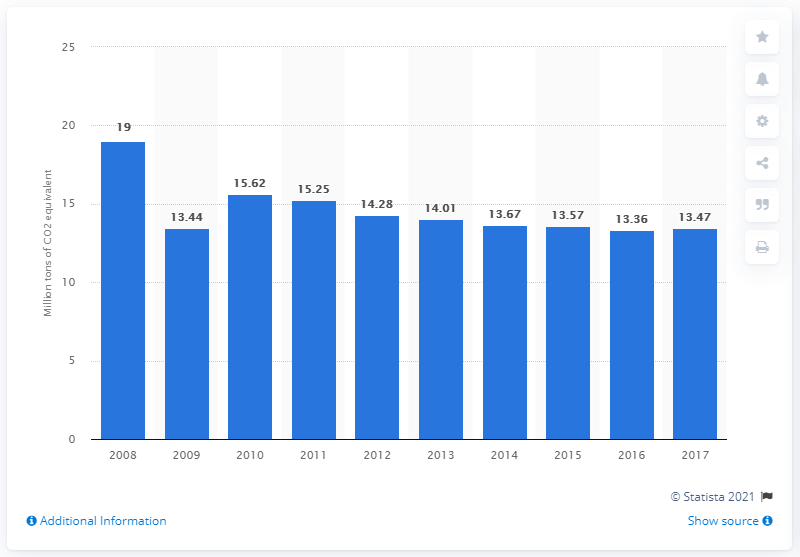Can we infer the impact of Belgium's policies on renewable energy based on this graph? While the graph indicates a downward trend in CO2 emissions which could correlate with effective renewable energy policies, it does not provide specific information on policy impact. To assess this, one would need to examine additional data on Belgium's renewable energy output, investments, and policy changes during these years. 